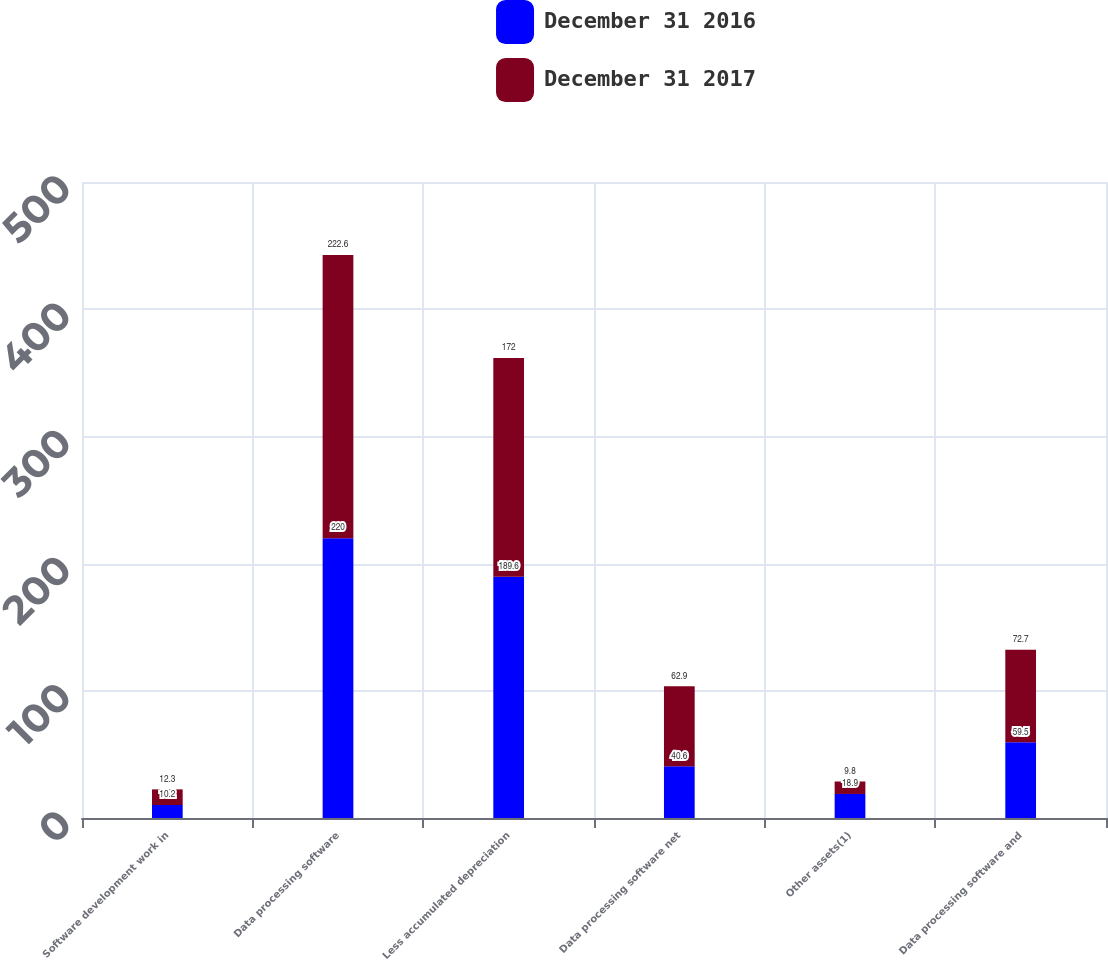<chart> <loc_0><loc_0><loc_500><loc_500><stacked_bar_chart><ecel><fcel>Software development work in<fcel>Data processing software<fcel>Less accumulated depreciation<fcel>Data processing software net<fcel>Other assets(1)<fcel>Data processing software and<nl><fcel>December 31 2016<fcel>10.2<fcel>220<fcel>189.6<fcel>40.6<fcel>18.9<fcel>59.5<nl><fcel>December 31 2017<fcel>12.3<fcel>222.6<fcel>172<fcel>62.9<fcel>9.8<fcel>72.7<nl></chart> 